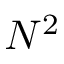Convert formula to latex. <formula><loc_0><loc_0><loc_500><loc_500>N ^ { 2 }</formula> 